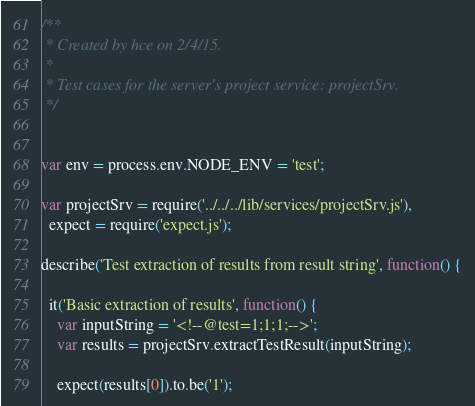<code> <loc_0><loc_0><loc_500><loc_500><_JavaScript_>/**
 * Created by hce on 2/4/15.
 *
 * Test cases for the server's project service: projectSrv.
 */


var env = process.env.NODE_ENV = 'test';

var projectSrv = require('../../../lib/services/projectSrv.js'),
  expect = require('expect.js');

describe('Test extraction of results from result string', function() {

  it('Basic extraction of results', function() {
    var inputString = '<!--@test=1;1;1;-->';
    var results = projectSrv.extractTestResult(inputString);

    expect(results[0]).to.be('1');</code> 